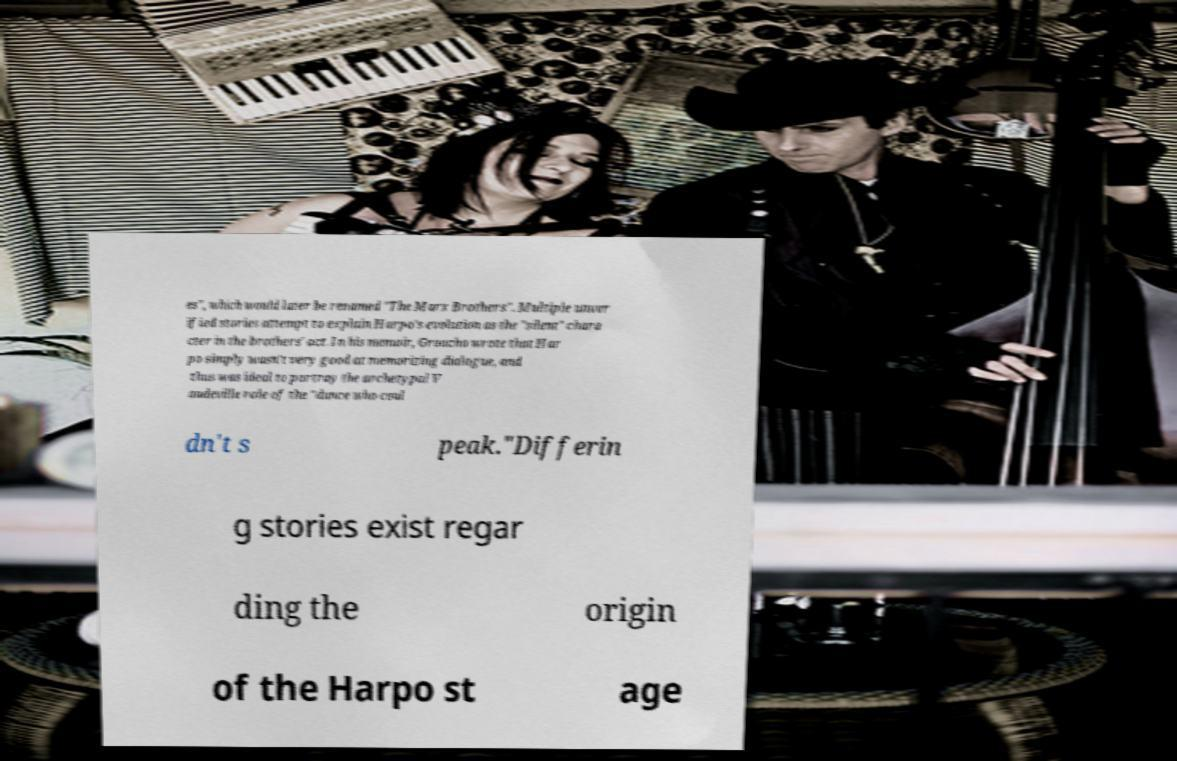Please read and relay the text visible in this image. What does it say? es", which would later be renamed "The Marx Brothers". Multiple unver ified stories attempt to explain Harpo's evolution as the "silent" chara cter in the brothers' act. In his memoir, Groucho wrote that Har po simply wasn't very good at memorizing dialogue, and thus was ideal to portray the archetypal V audeville role of the "dunce who coul dn't s peak."Differin g stories exist regar ding the origin of the Harpo st age 